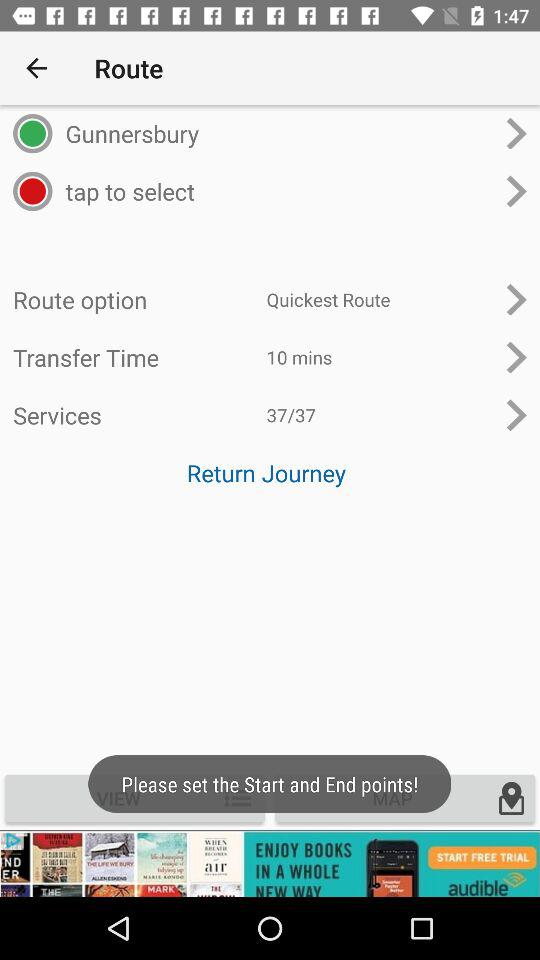What is the transfer time? The transfer time is 10 minutes. 